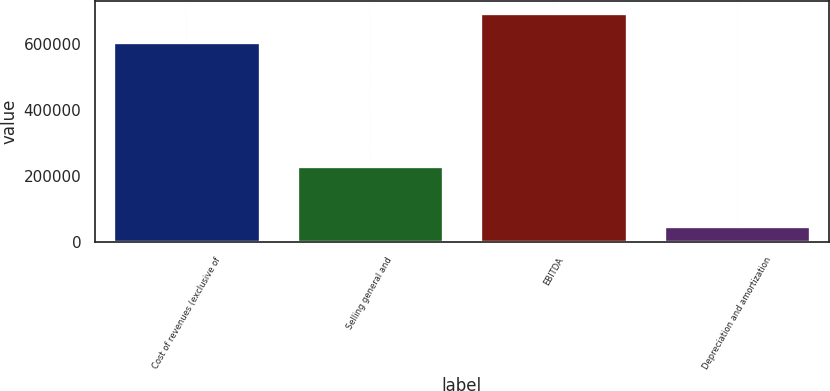Convert chart to OTSL. <chart><loc_0><loc_0><loc_500><loc_500><bar_chart><fcel>Cost of revenues (exclusive of<fcel>Selling general and<fcel>EBITDA<fcel>Depreciation and amortization<nl><fcel>607174<fcel>231359<fcel>695915<fcel>50624<nl></chart> 